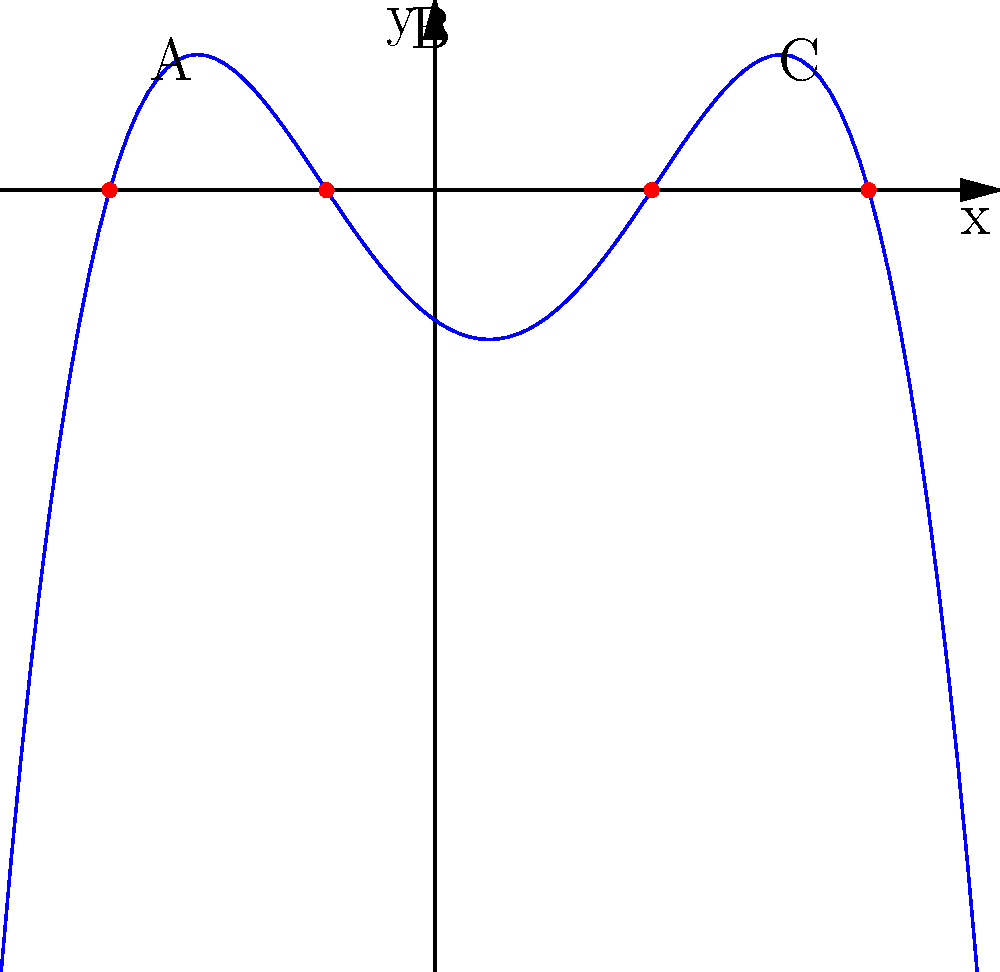The graph represents a client's progress in overcoming social anxiety, where the x-axis represents time (in months) and the y-axis represents anxiety levels. The turning points (local maxima and minima) of the polynomial function represent key milestones in the client's journey. If the polynomial function is of the form $f(x)=-0.05(x+3)(x+1)(x-2)(x-4)$, at which month (x-value) does the client experience their lowest anxiety level after starting the program? To find the month when the client experiences their lowest anxiety level after starting the program, we need to:

1. Identify the turning points of the function.
2. Determine which turning point represents the minimum after x = 0.

Steps:
1. The roots of the polynomial are at x = -3, -1, 2, and 4.
2. The turning points occur between these roots.
3. There are three turning points: two local maxima and one local minimum.
4. The local minimum occurs between x = -1 and x = 2.
5. To find the exact x-value of this minimum, we can differentiate the function and set it to zero:

   $f'(x) = -0.05((x+1)(x-2)(x-4) + (x+3)(x-2)(x-4) + (x+3)(x+1)(x-4) + (x+3)(x+1)(x-2))$
   
   Setting $f'(x) = 0$ and solving would give us the exact x-value.

6. However, from the graph, we can see that this minimum occurs at approximately x = 0.5.

7. Since the question asks for the lowest anxiety level after starting the program (x = 0), this minimum at x ≈ 0.5 is the answer we're looking for.

Therefore, the client experiences their lowest anxiety level approximately 0.5 months (or about 2 weeks) after starting the program.
Answer: 0.5 months 